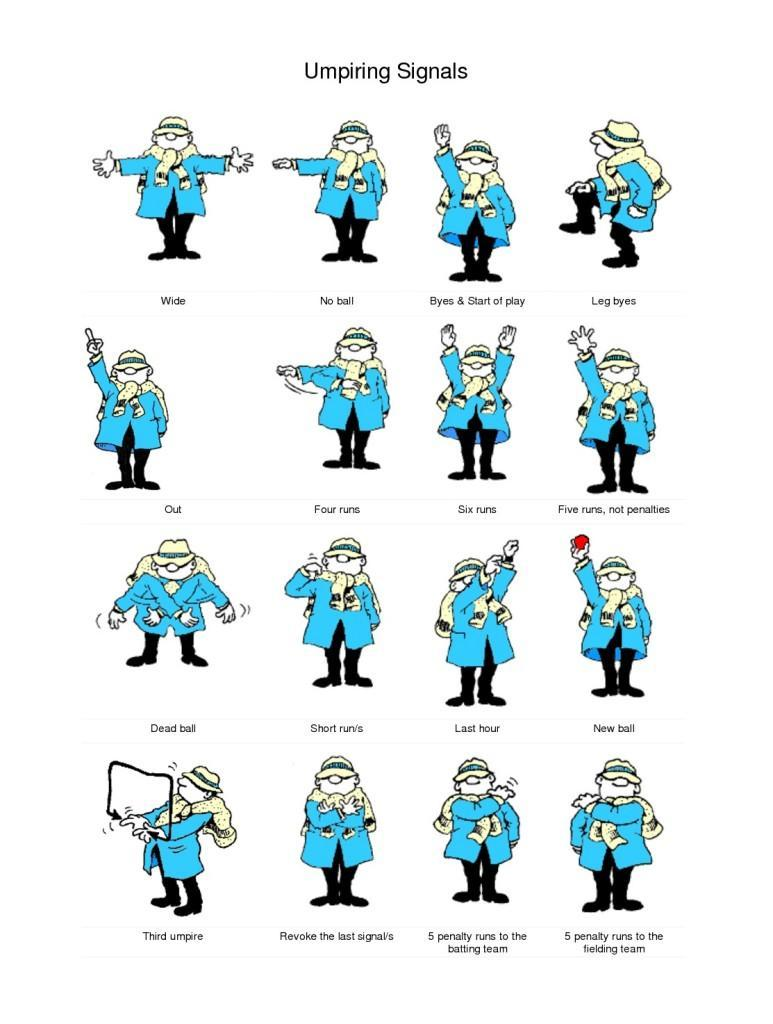What is the eighth signal mentioned in this infographic?
Answer the question with a short phrase. Five runs, not penalties What is the ninth signal mentioned in this infographic? Dead ball What is the eleventh signal mentioned in this infographic? Last hour What is the seventh signal mentioned in this infographic? Six runs What is the sixth signal mentioned in this infographic? Four runs 